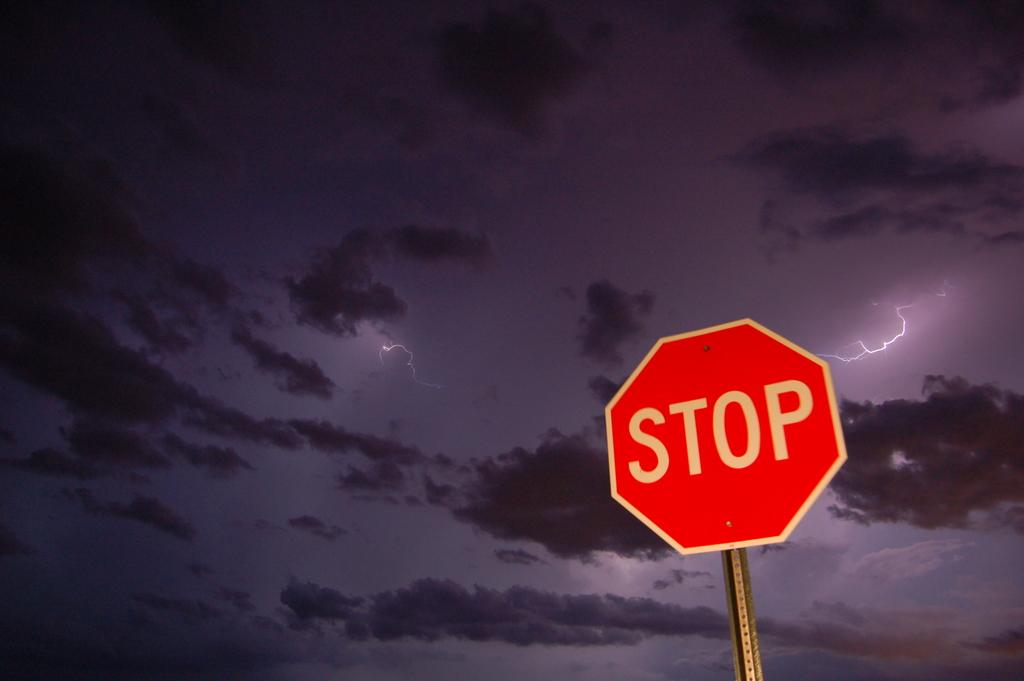What is this sign telling us to do?
Keep it short and to the point. Stop. Does that stop sign look red and white?
Provide a succinct answer. Yes. 